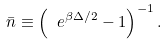<formula> <loc_0><loc_0><loc_500><loc_500>\bar { n } \equiv \left ( \ e ^ { \beta \Delta / 2 } - 1 \right ) ^ { - 1 } .</formula> 